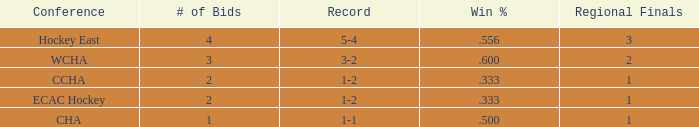For the Hockey East conference, what is the total number of win percentages when there are less than 4 bids? 0.0. 